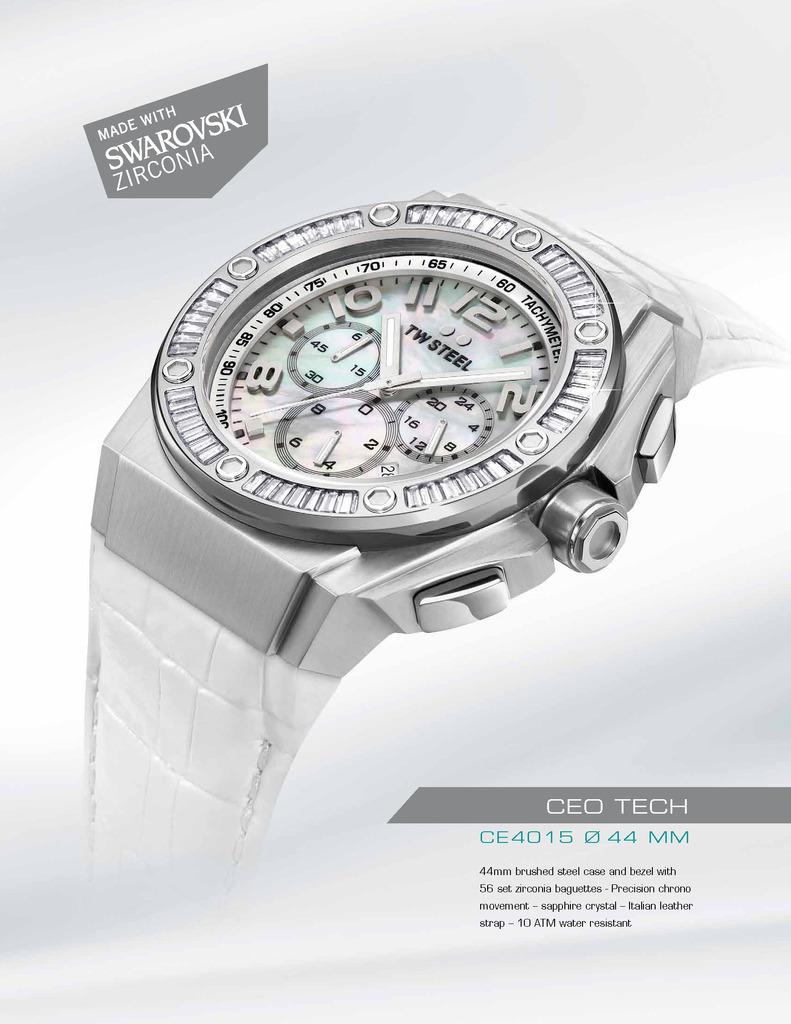What does it say on the face of the clock?
Your answer should be compact. Tw steel. What is this watch made with?
Keep it short and to the point. Swarovski zirconia. 